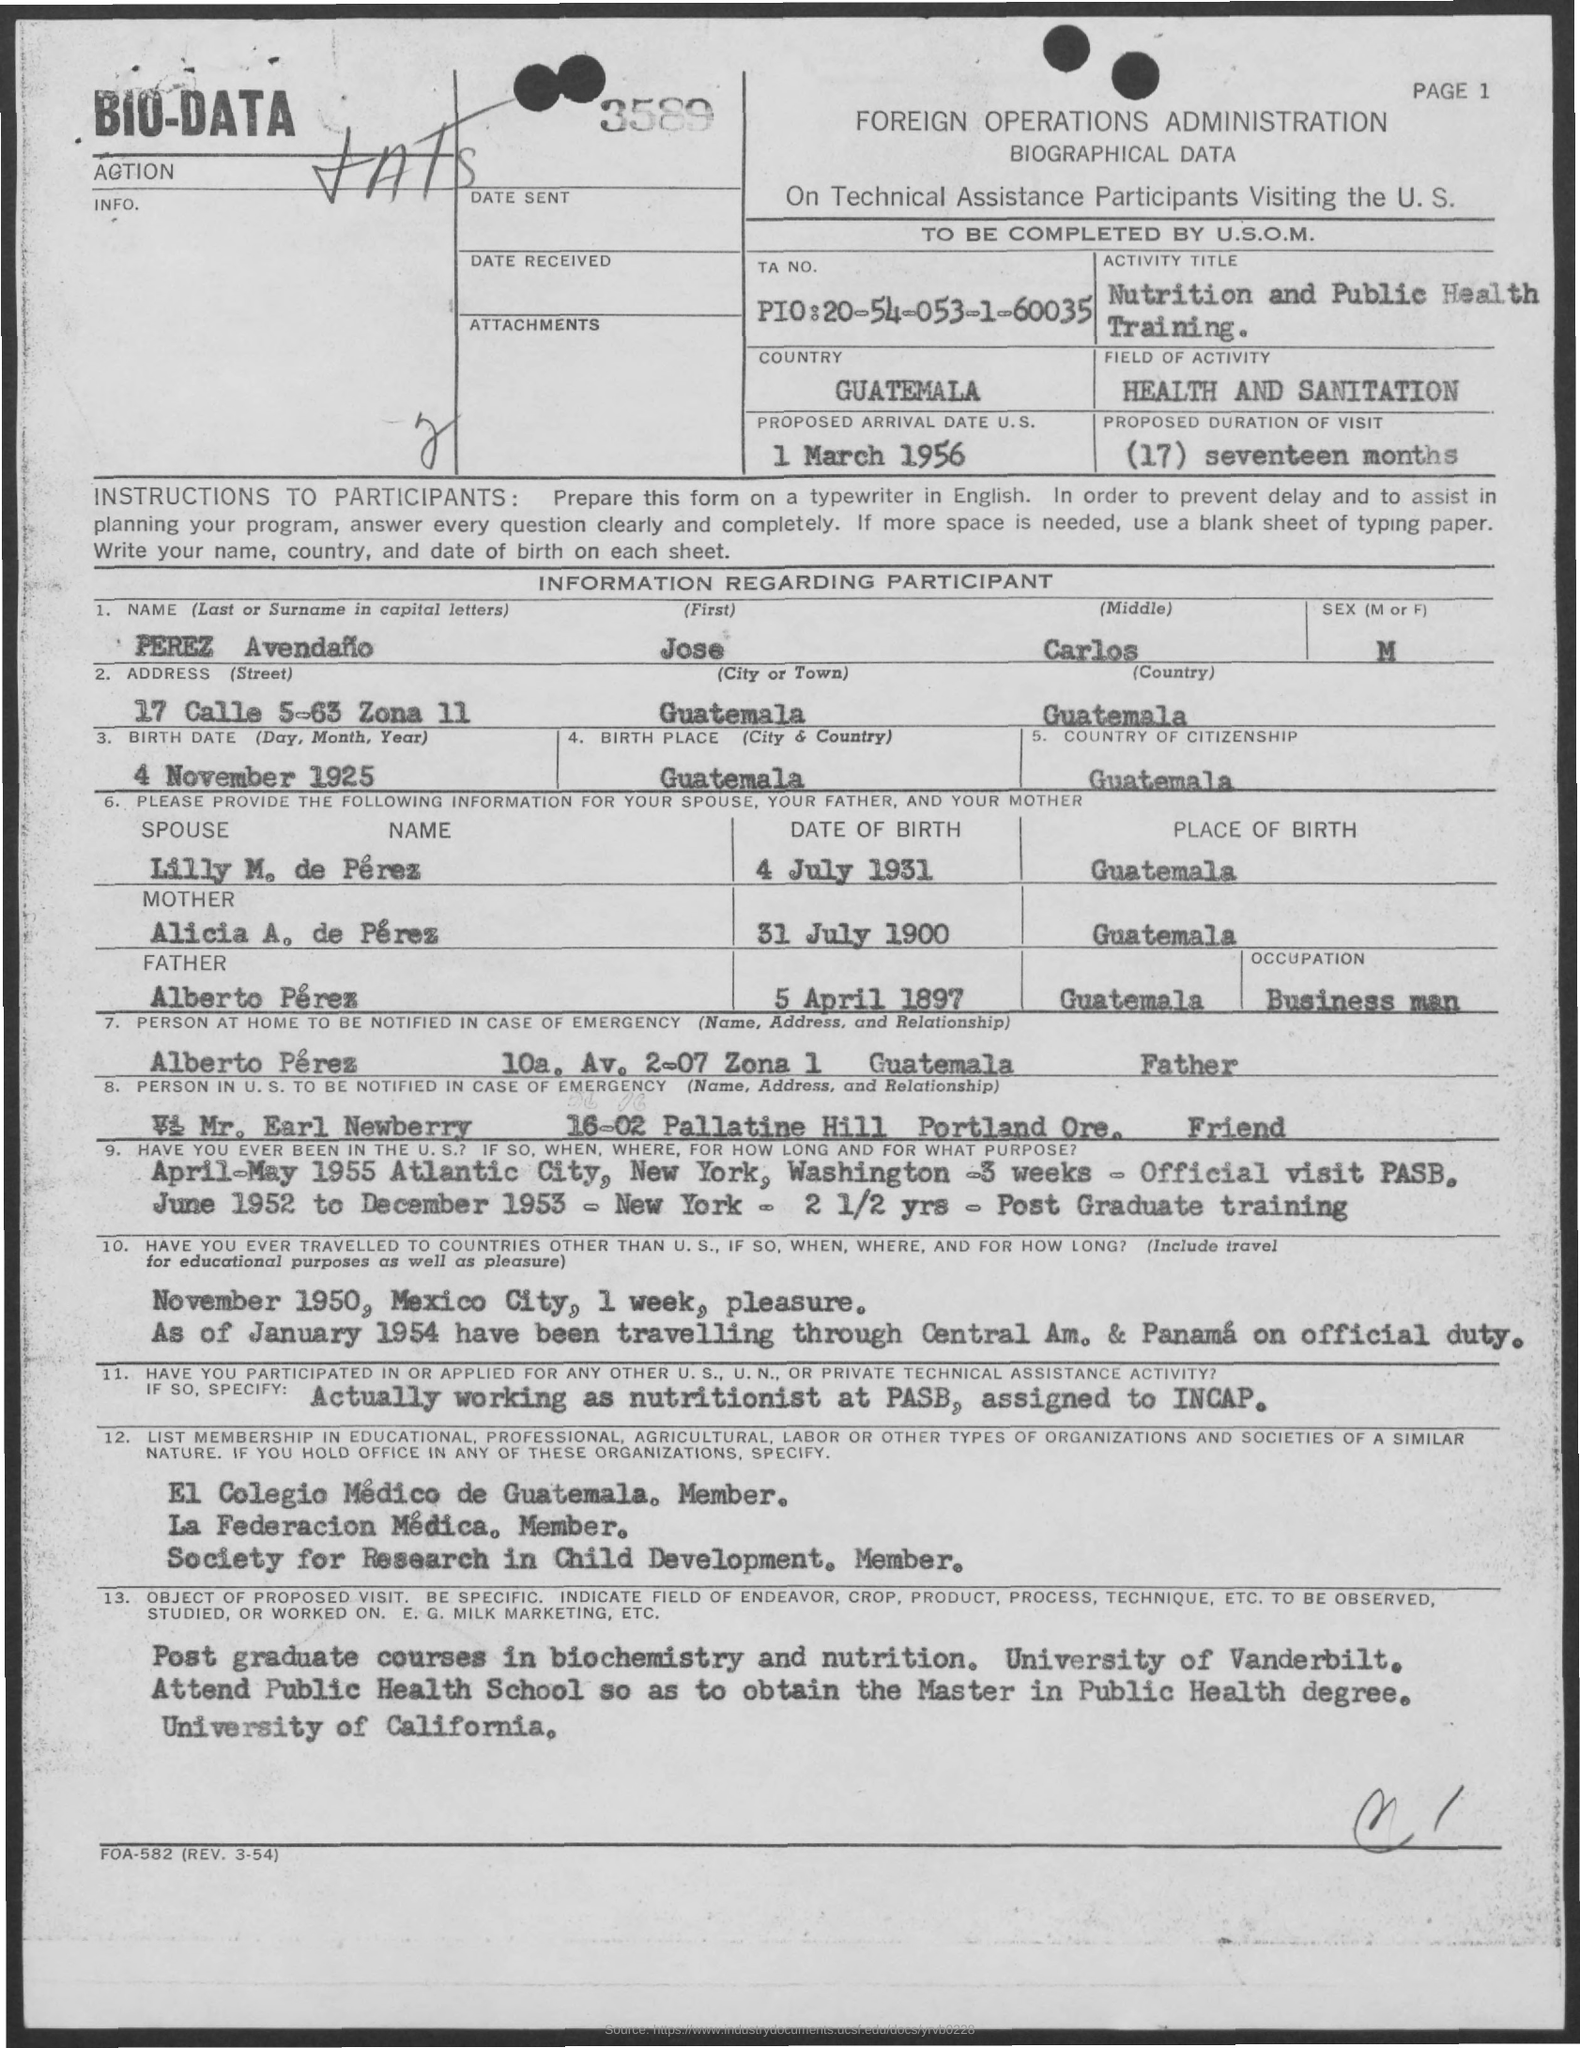Specify some key components in this picture. The proposed duration of the visit is seventeen months. The participant's first name is Jose. 